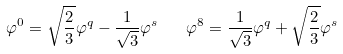Convert formula to latex. <formula><loc_0><loc_0><loc_500><loc_500>\varphi ^ { 0 } = \sqrt { \frac { 2 } { 3 } } \varphi ^ { q } - \frac { 1 } { \sqrt { 3 } } \varphi ^ { s } \quad \varphi ^ { 8 } = \frac { 1 } { \sqrt { 3 } } \varphi ^ { q } + \sqrt { \frac { 2 } { 3 } } \varphi ^ { s }</formula> 